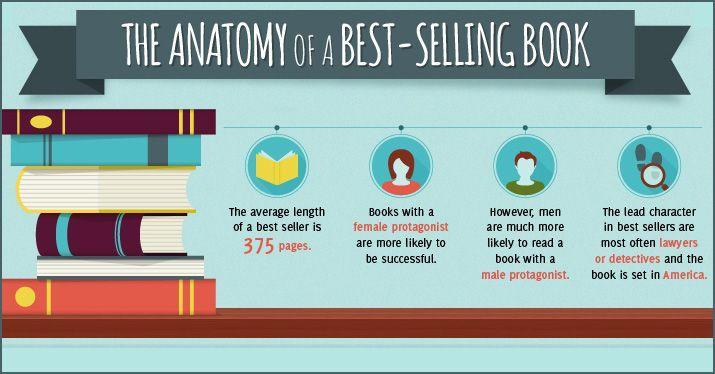How many books with yellow color in this infographic?
Answer the question with a short phrase. 2 How many books are in this infographic? 7 